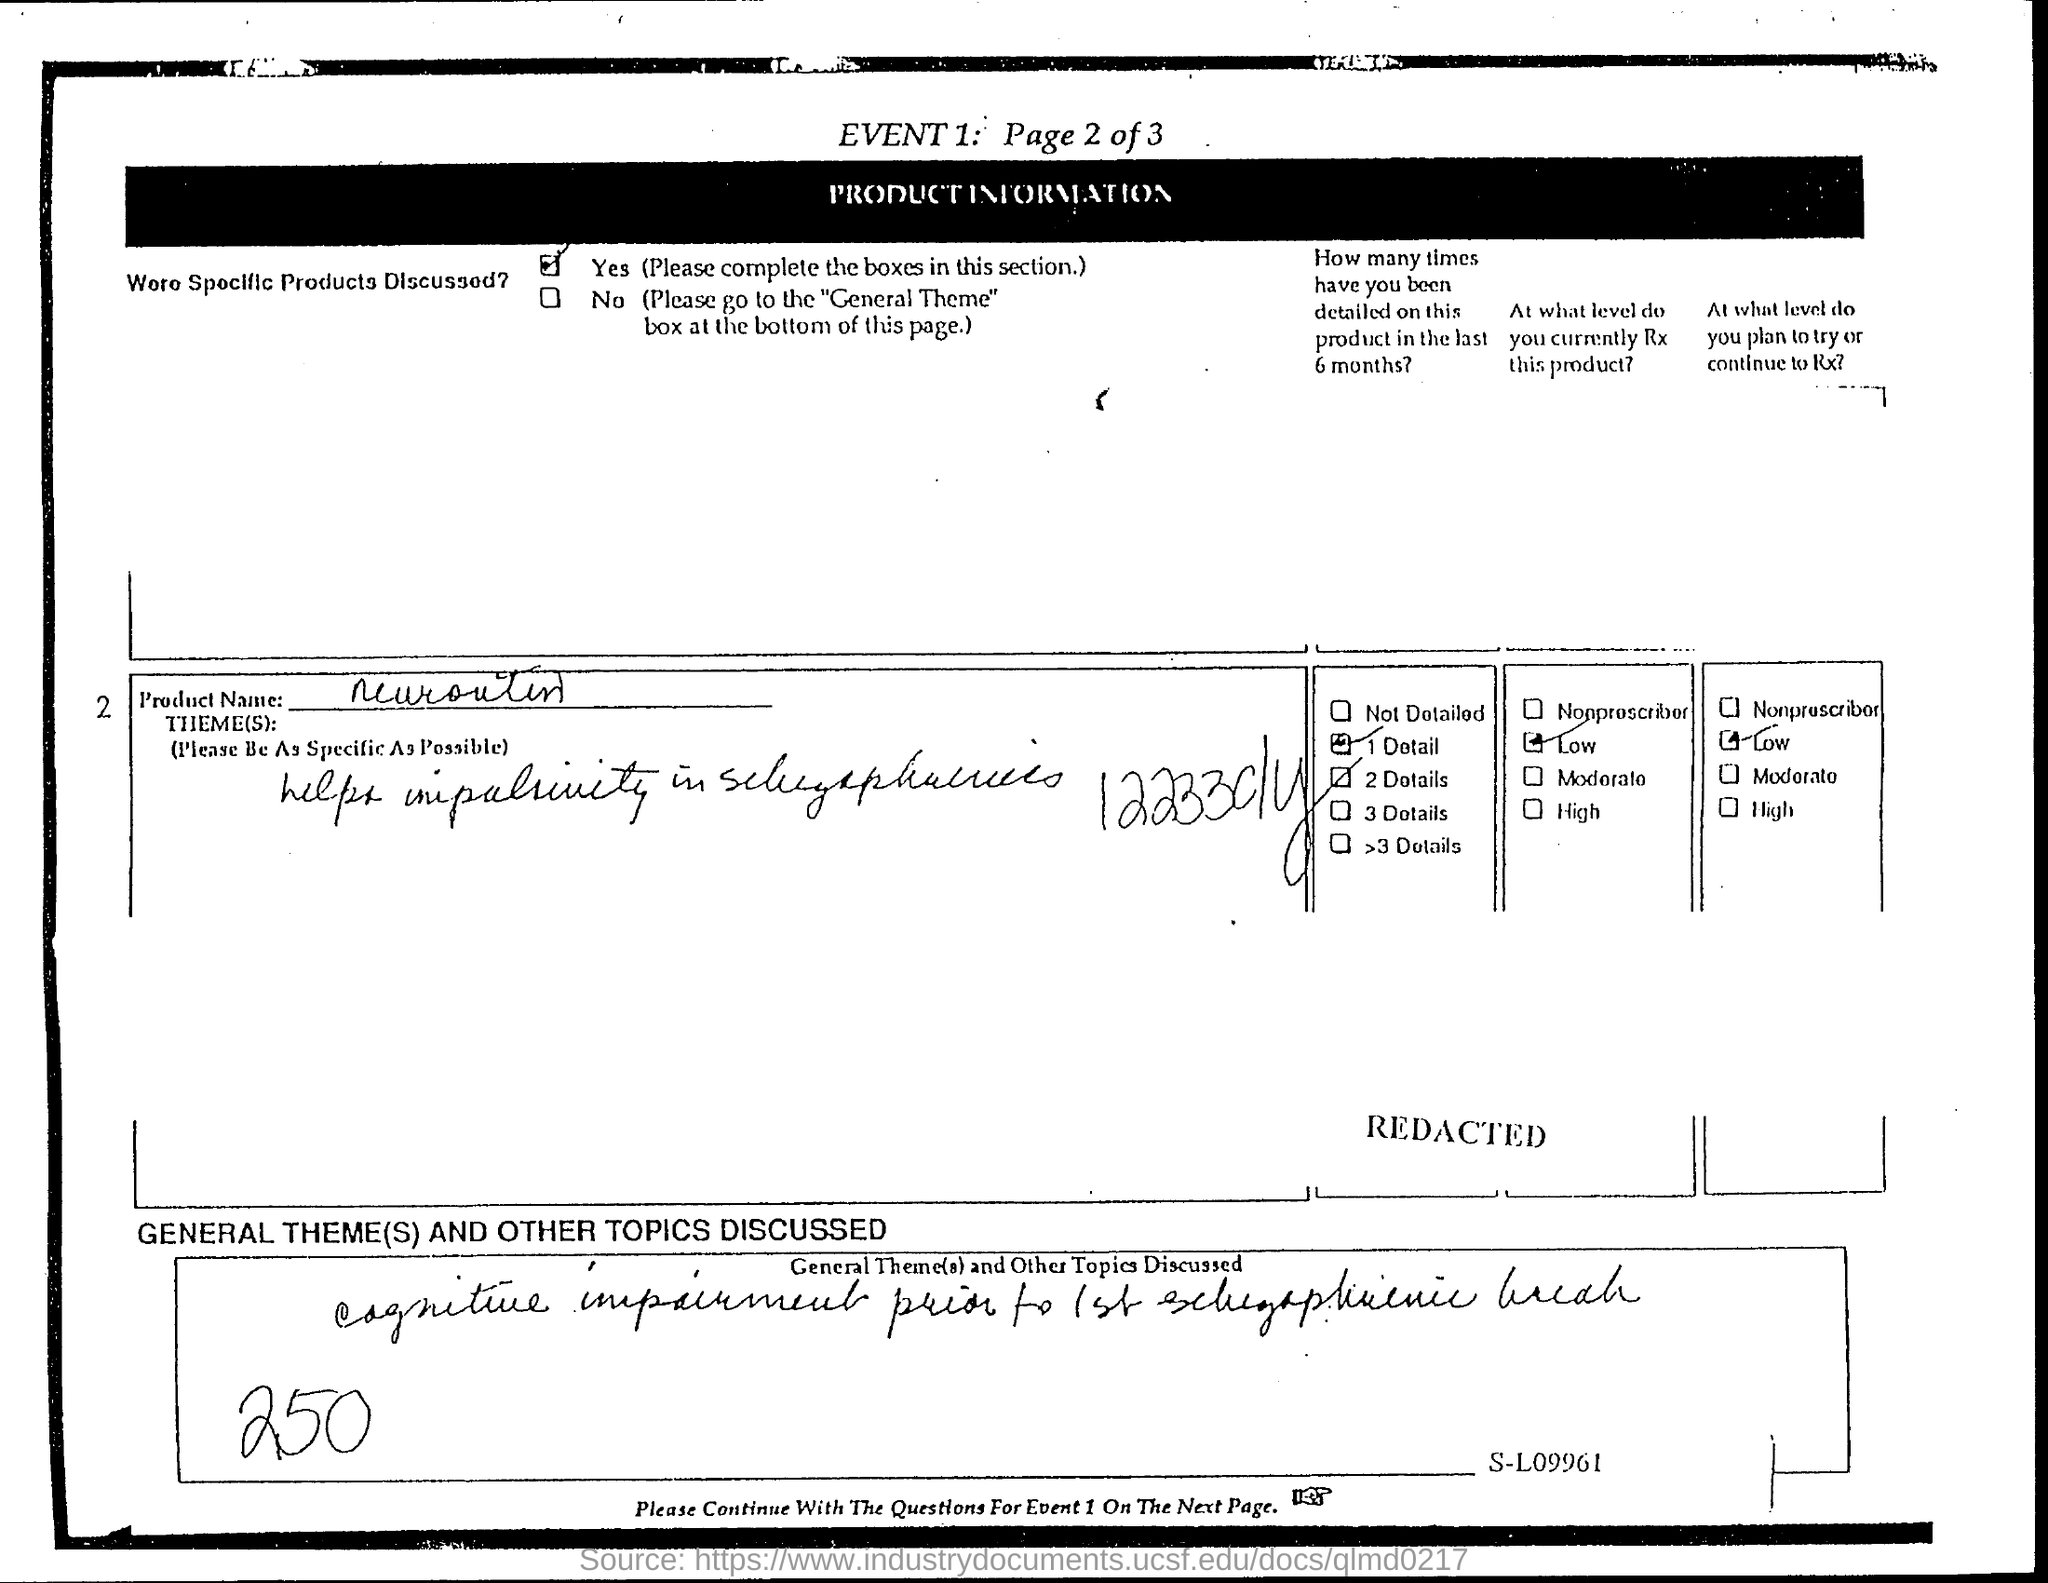List a handful of essential elements in this visual. The product name is Neurontin. 